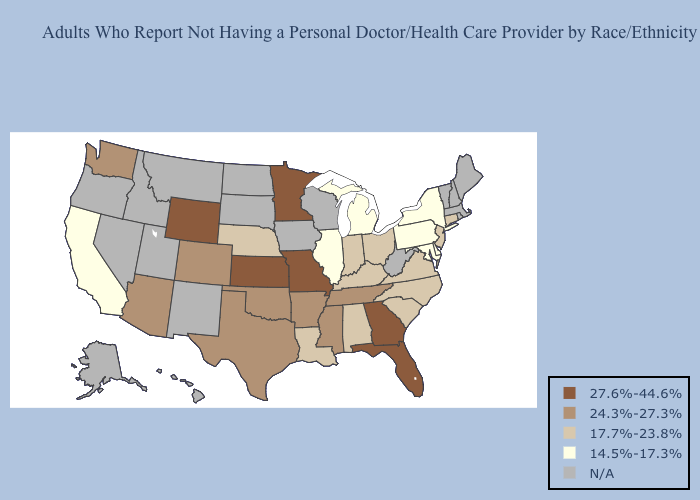What is the lowest value in the USA?
Be succinct. 14.5%-17.3%. Among the states that border Kentucky , does Illinois have the lowest value?
Answer briefly. Yes. What is the highest value in the USA?
Concise answer only. 27.6%-44.6%. Which states have the lowest value in the USA?
Keep it brief. California, Delaware, Illinois, Maryland, Michigan, New York, Pennsylvania. Among the states that border Oregon , which have the highest value?
Answer briefly. Washington. What is the value of Washington?
Keep it brief. 24.3%-27.3%. Does the map have missing data?
Be succinct. Yes. What is the value of Wyoming?
Short answer required. 27.6%-44.6%. What is the lowest value in states that border Rhode Island?
Write a very short answer. 17.7%-23.8%. Which states have the highest value in the USA?
Give a very brief answer. Florida, Georgia, Kansas, Minnesota, Missouri, Wyoming. What is the value of North Carolina?
Concise answer only. 17.7%-23.8%. What is the value of New Jersey?
Answer briefly. 17.7%-23.8%. Does North Carolina have the lowest value in the USA?
Be succinct. No. 